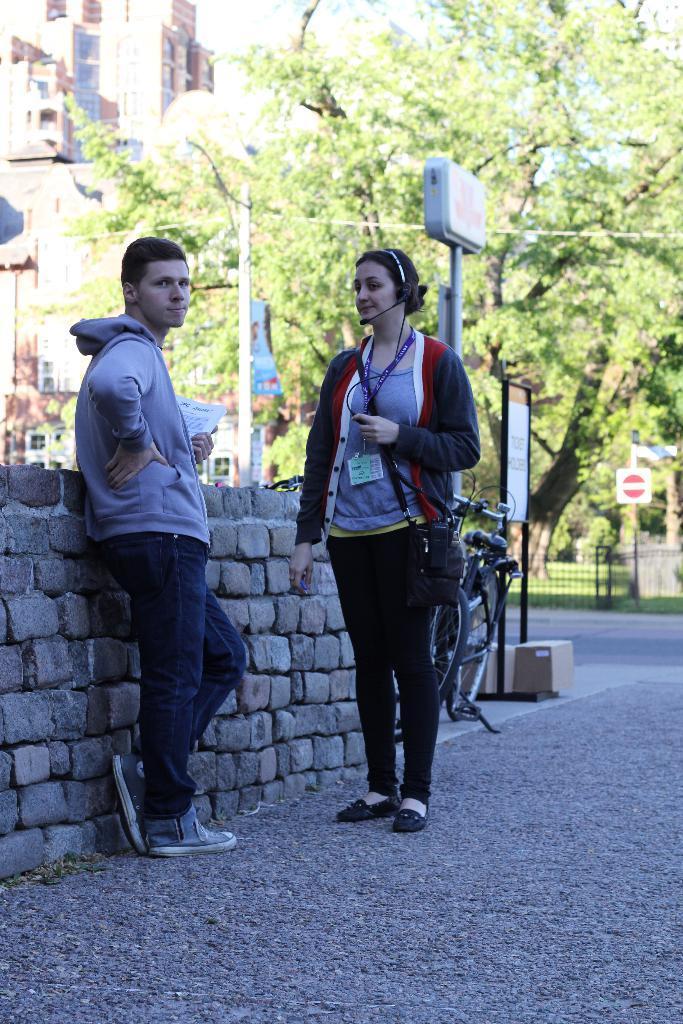Describe this image in one or two sentences. In this picture there is a woman who is wearing jacket, t-shirt, shoe and headphones. She is holding a cable and purse. In front of her there is a man. He is standing near to the stone wall. Backside of them there is a bicycle near to the board and pole. In the background we can see buildings, trees, street lights, sign board, fencing and grass. At the top there is a sky. 